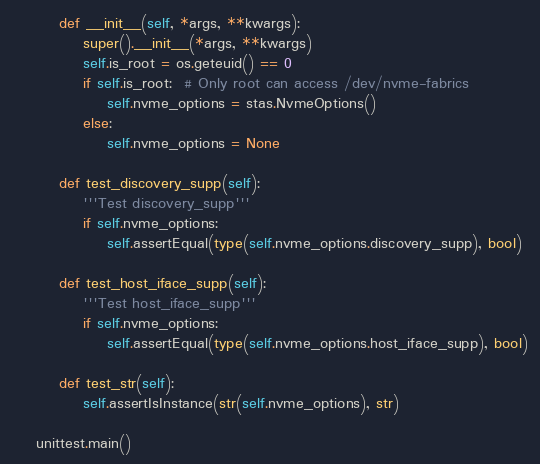<code> <loc_0><loc_0><loc_500><loc_500><_Python_>        def __init__(self, *args, **kwargs):
            super().__init__(*args, **kwargs)
            self.is_root = os.geteuid() == 0
            if self.is_root:  # Only root can access /dev/nvme-fabrics
                self.nvme_options = stas.NvmeOptions()
            else:
                self.nvme_options = None

        def test_discovery_supp(self):
            '''Test discovery_supp'''
            if self.nvme_options:
                self.assertEqual(type(self.nvme_options.discovery_supp), bool)

        def test_host_iface_supp(self):
            '''Test host_iface_supp'''
            if self.nvme_options:
                self.assertEqual(type(self.nvme_options.host_iface_supp), bool)

        def test_str(self):
            self.assertIsInstance(str(self.nvme_options), str)

    unittest.main()
</code> 